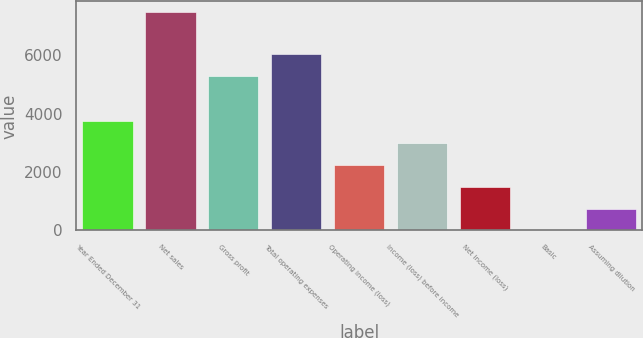Convert chart. <chart><loc_0><loc_0><loc_500><loc_500><bar_chart><fcel>Year Ended December 31<fcel>Net sales<fcel>Gross profit<fcel>Total operating expenses<fcel>Operating income (loss)<fcel>Income (loss) before income<fcel>Net income (loss)<fcel>Basic<fcel>Assuming dilution<nl><fcel>3738.58<fcel>7477<fcel>5304<fcel>6051.68<fcel>2243.22<fcel>2990.9<fcel>1495.54<fcel>0.18<fcel>747.86<nl></chart> 